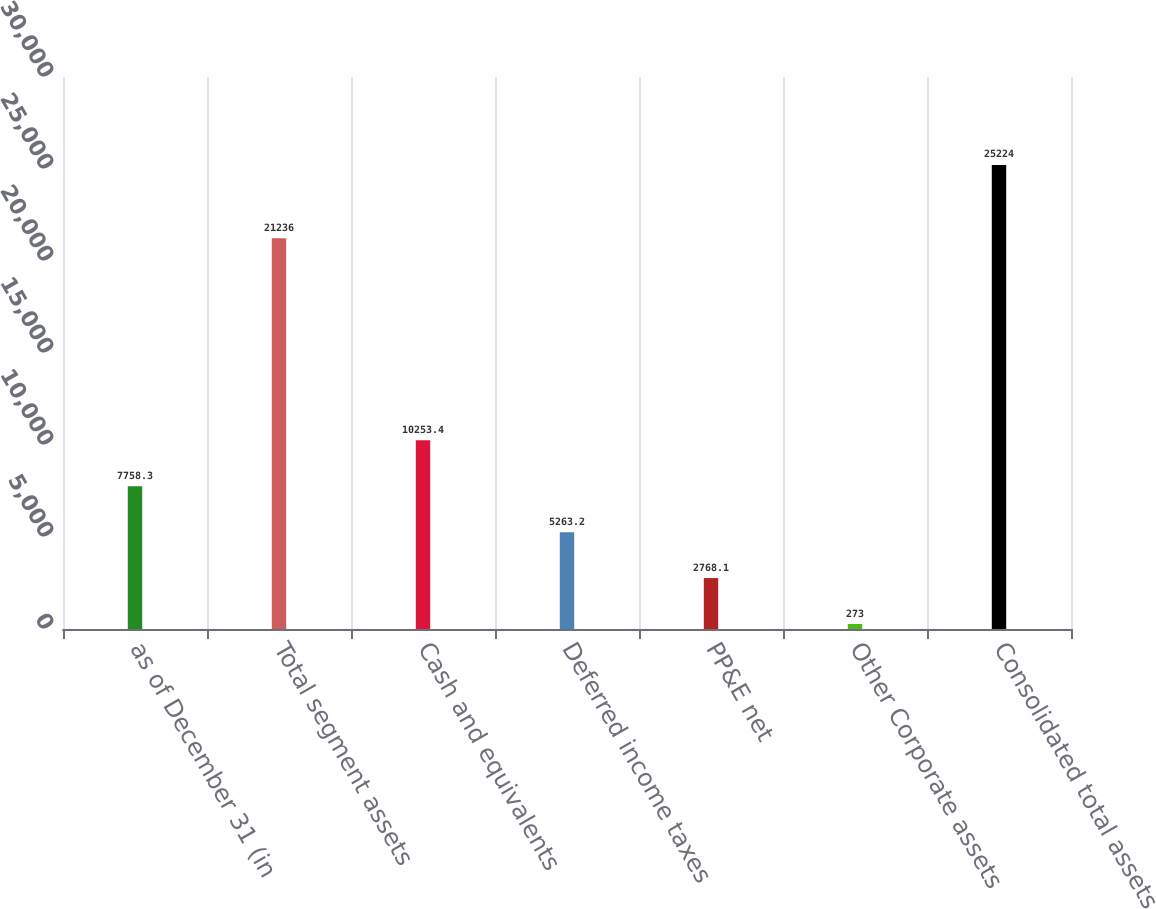Convert chart. <chart><loc_0><loc_0><loc_500><loc_500><bar_chart><fcel>as of December 31 (in<fcel>Total segment assets<fcel>Cash and equivalents<fcel>Deferred income taxes<fcel>PP&E net<fcel>Other Corporate assets<fcel>Consolidated total assets<nl><fcel>7758.3<fcel>21236<fcel>10253.4<fcel>5263.2<fcel>2768.1<fcel>273<fcel>25224<nl></chart> 